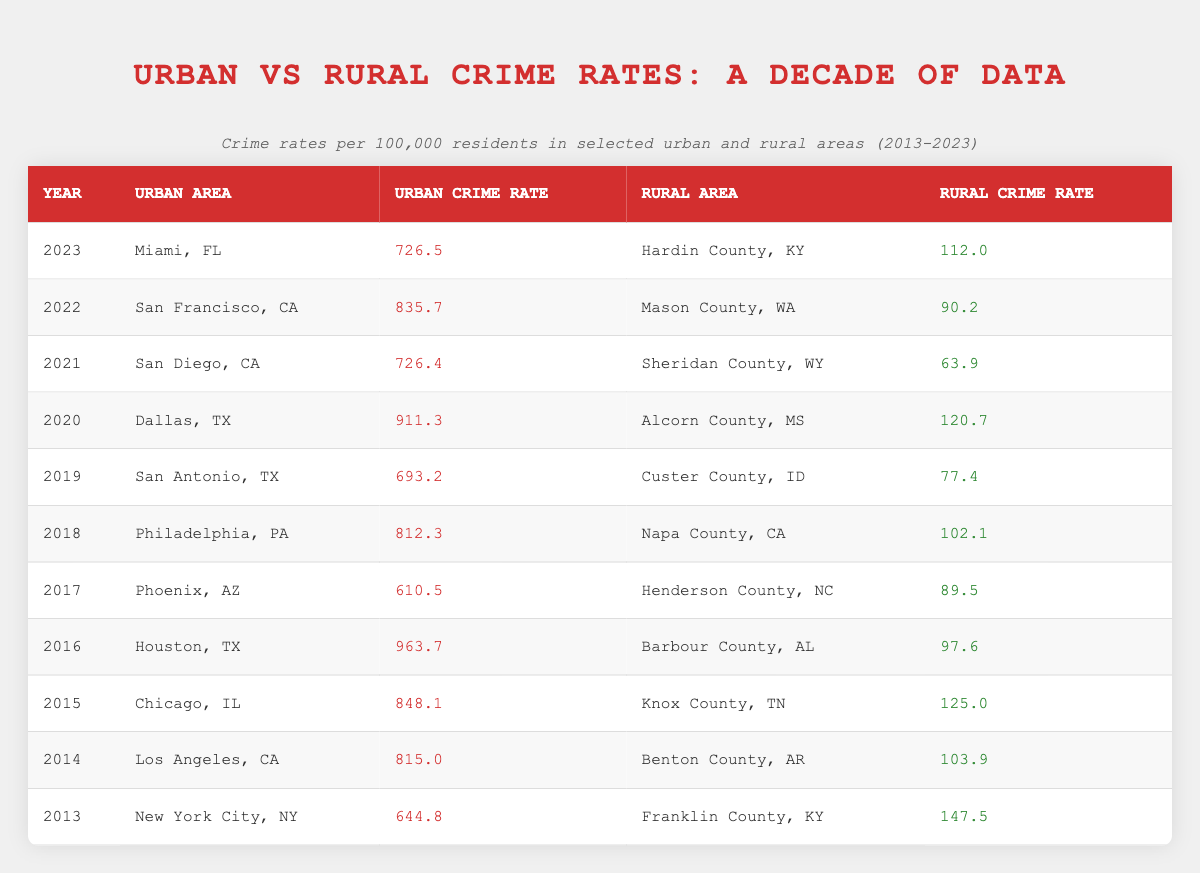What was the urban crime rate in Chicago, IL in 2015? By locating the row for the year 2015 and the urban area Chicago, IL, the urban crime rate is given as 848.1.
Answer: 848.1 What is the rural crime rate in Mason County, WA for the year 2022? Looking at the row for the year 2022 in the table, the rural crime rate for Mason County, WA is provided as 90.2.
Answer: 90.2 Which urban area had the highest crime rate in 2016? The row for 2016 indicates that Houston, TX had the highest urban crime rate at 963.7 compared to other urban areas that year.
Answer: Houston, TX Is the rural crime rate higher in Franklin County, KY or Hardin County, KY? Franklin County, KY has a rural crime rate of 147.5 (2013), and Hardin County, KY has a rural crime rate of 112.0 (2023). Comparing these, Franklin County has the higher rate.
Answer: Yes What was the average urban crime rate across the decade from 2013 to 2023? Summing the urban crime rates from each year: (644.8 + 815.0 + 848.1 + 963.7 + 610.5 + 812.3 + 693.2 + 911.3 + 726.4 + 835.7 + 726.5) = 8443.7. Then dividing by 11 (the number of years), the average is approximately 768.6.
Answer: 768.6 Did the urban crime rate in San Antonio, TX decrease from 2019 to 2023? In 2019, the urban crime rate for San Antonio, TX was 693.2, and in 2023 it is 726.5. Since 726.5 is greater than 693.2, it indicates an increase.
Answer: No What is the difference between the urban crime rate in Los Angeles, CA (2014) and in Dallas, TX (2020)? The urban crime rate in Los Angeles, CA for 2014 is 815.0, and in Dallas, TX for 2020 it's 911.3. The difference is calculated as 911.3 - 815.0 = 96.3.
Answer: 96.3 Was the rural crime rate lower than 100.0 in all selected areas from 2017 to 2023? Analyzing the rural crime rates from 2017 (89.5) to 2023 (112.0), it is clear that the rates were not consistently below 100 as the rate for 2023 exceeds it.
Answer: No How many urban areas reported a crime rate over 800 in the year 2021? Checking the urban crime rates for 2021, only San Diego, CA with a rate of 726.4 does not exceed 800; therefore, no urban areas had rates over 800.
Answer: 0 